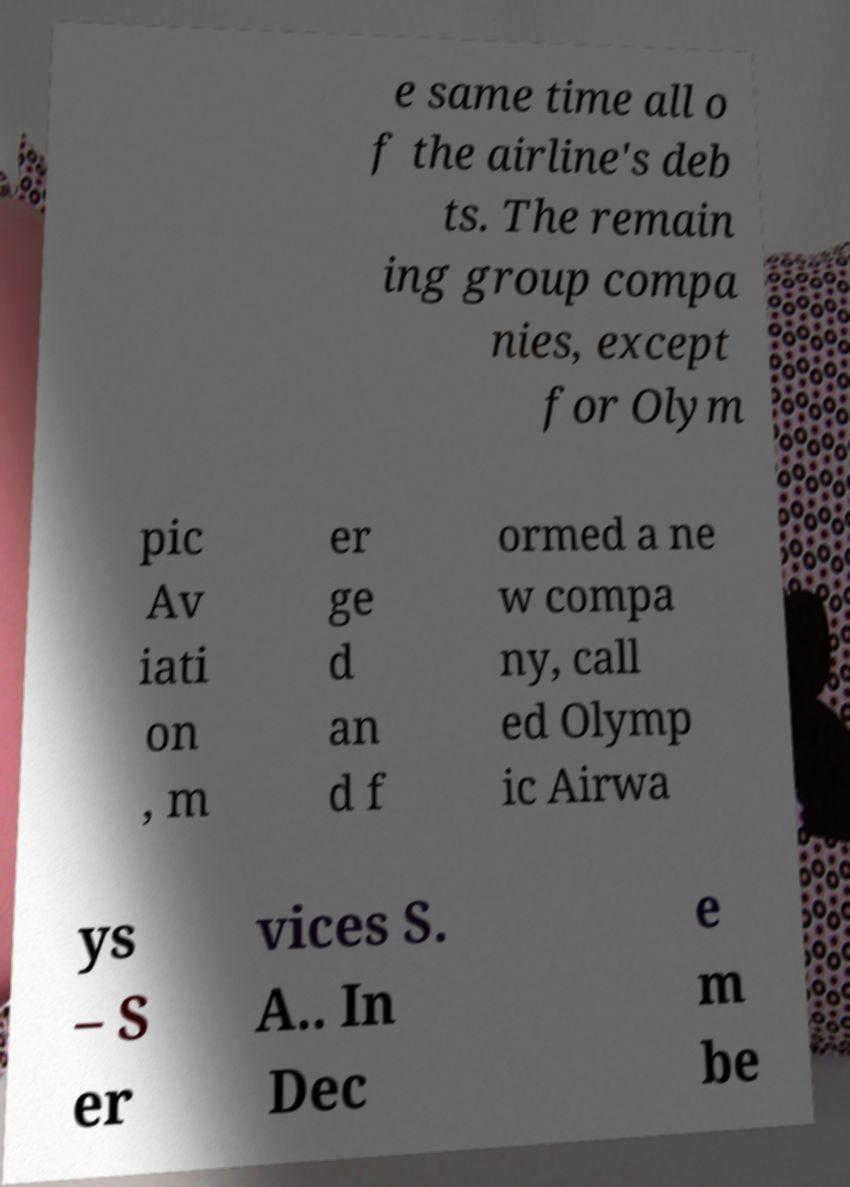There's text embedded in this image that I need extracted. Can you transcribe it verbatim? e same time all o f the airline's deb ts. The remain ing group compa nies, except for Olym pic Av iati on , m er ge d an d f ormed a ne w compa ny, call ed Olymp ic Airwa ys – S er vices S. A.. In Dec e m be 